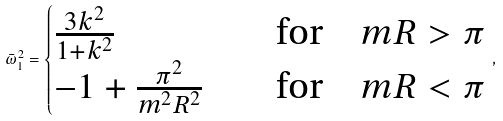Convert formula to latex. <formula><loc_0><loc_0><loc_500><loc_500>\bar { \omega } _ { 1 } ^ { 2 } = \begin{cases} \frac { 3 k ^ { 2 } } { 1 + k ^ { 2 } } & \quad \text {for} \quad m R > \pi \\ - 1 + \frac { \pi ^ { 2 } } { m ^ { 2 } R ^ { 2 } } & \quad \text {for} \quad m R < \pi \end{cases} \, ,</formula> 